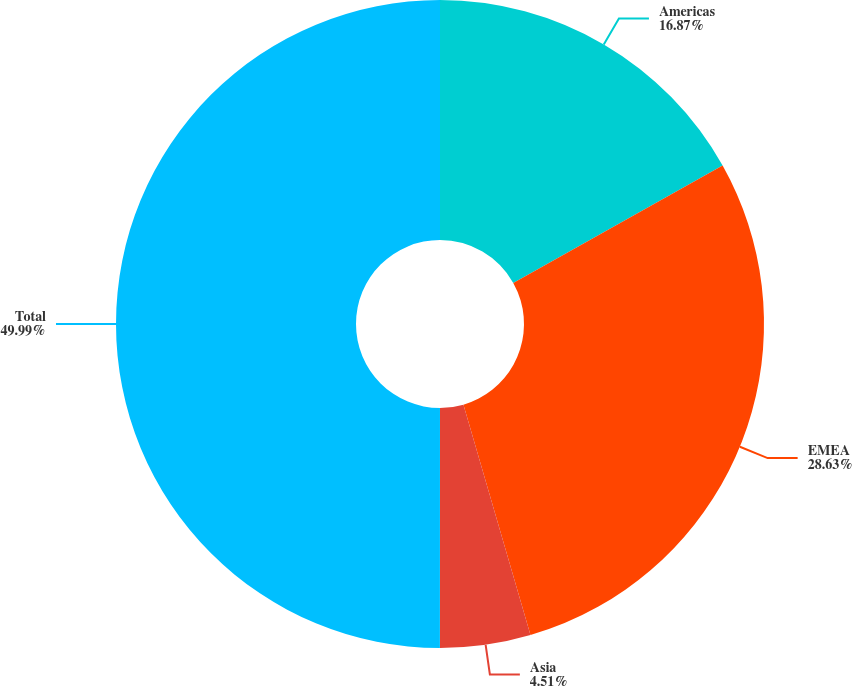Convert chart to OTSL. <chart><loc_0><loc_0><loc_500><loc_500><pie_chart><fcel>Americas<fcel>EMEA<fcel>Asia<fcel>Total<nl><fcel>16.87%<fcel>28.63%<fcel>4.51%<fcel>50.0%<nl></chart> 